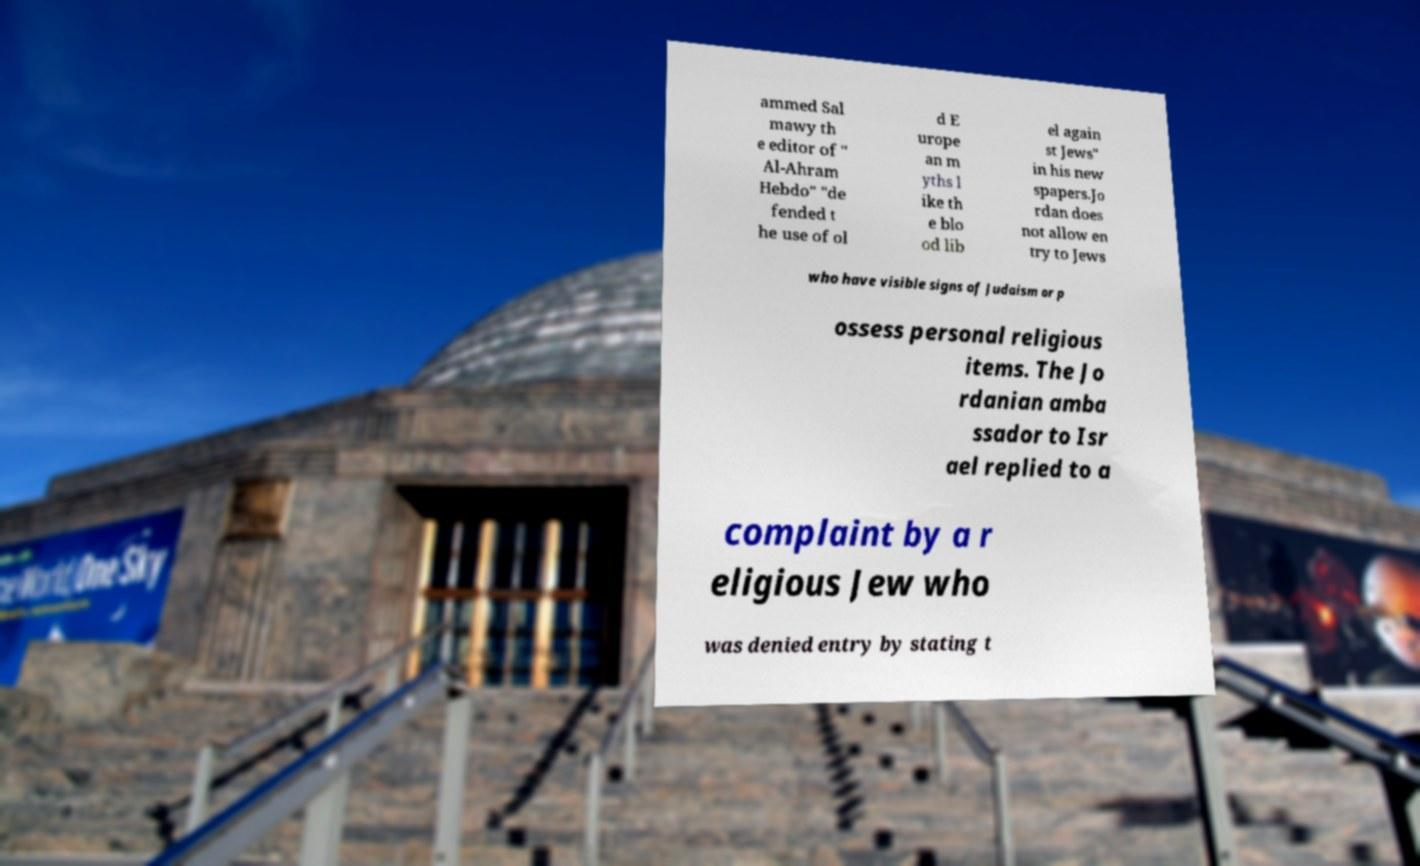There's text embedded in this image that I need extracted. Can you transcribe it verbatim? ammed Sal mawy th e editor of " Al-Ahram Hebdo" "de fended t he use of ol d E urope an m yths l ike th e blo od lib el again st Jews" in his new spapers.Jo rdan does not allow en try to Jews who have visible signs of Judaism or p ossess personal religious items. The Jo rdanian amba ssador to Isr ael replied to a complaint by a r eligious Jew who was denied entry by stating t 